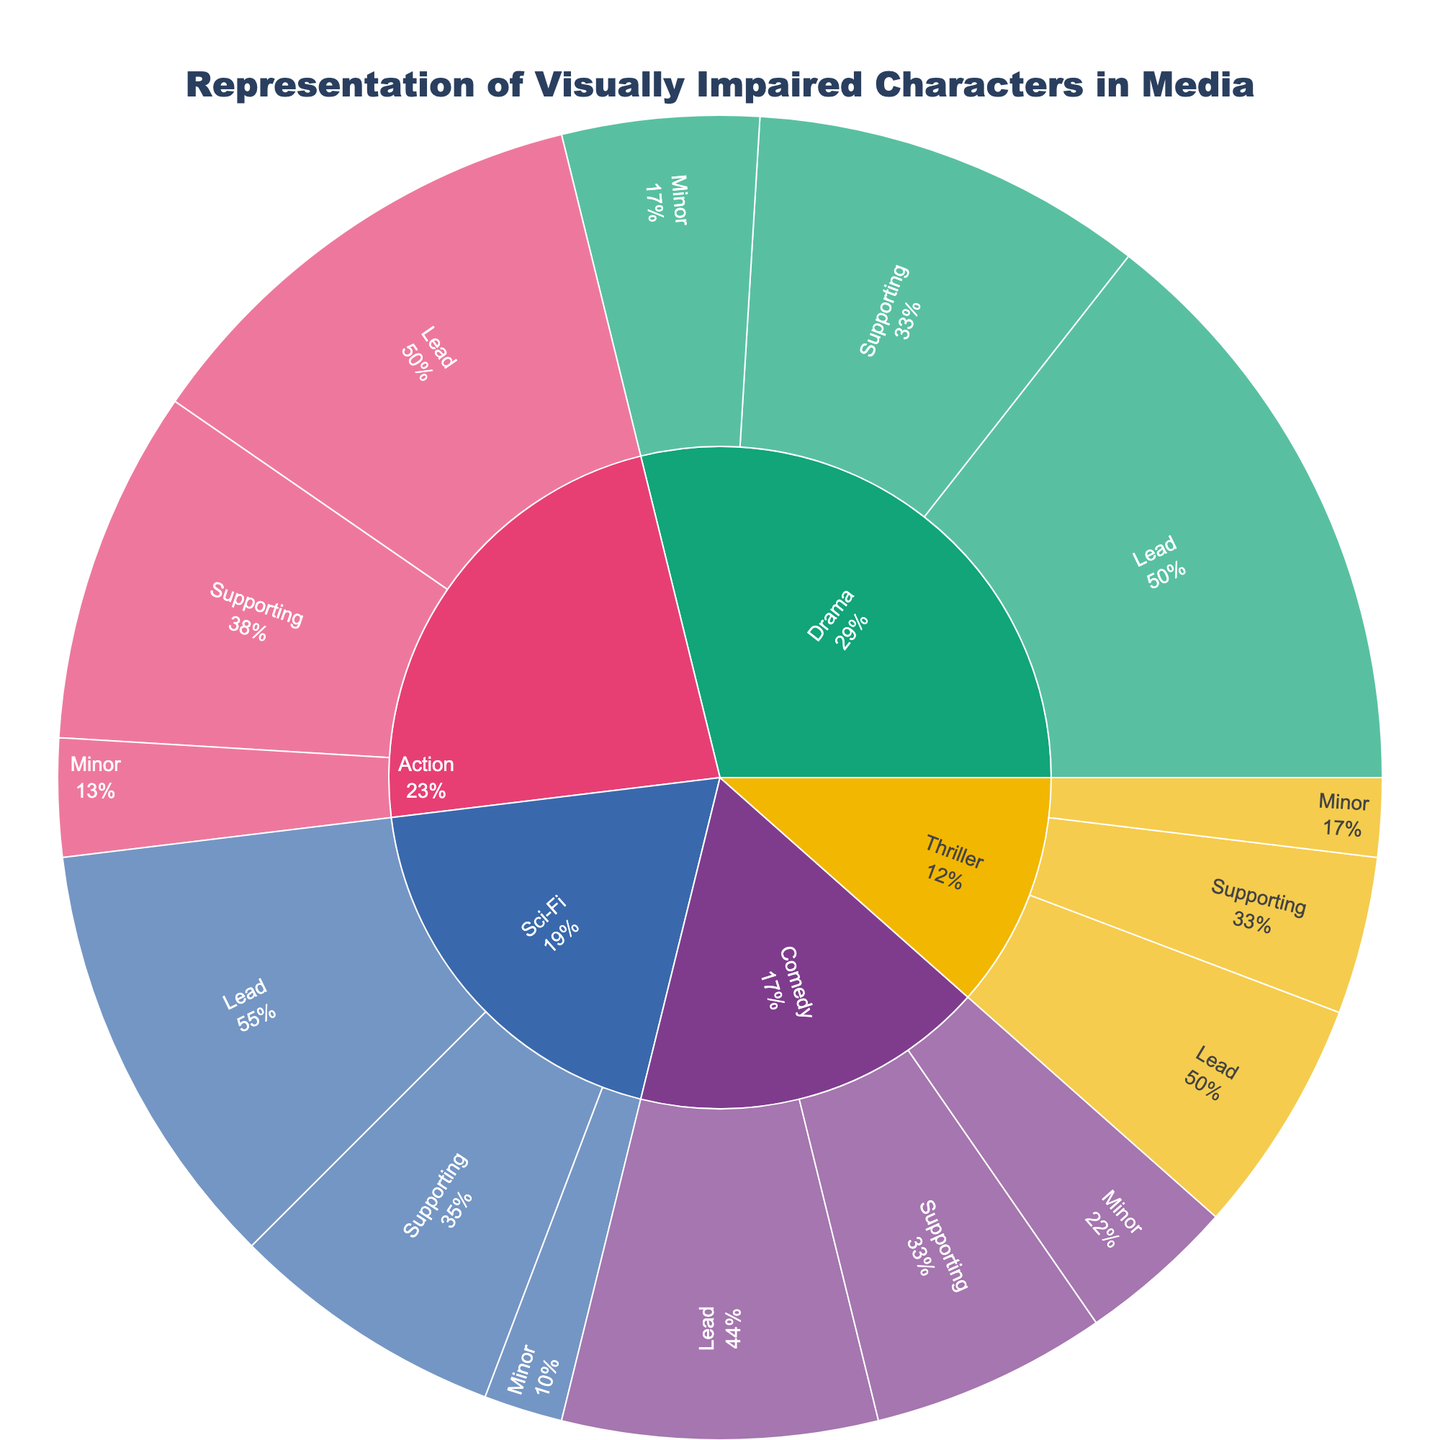What is the title of the Sunburst Plot? The title of the plot is positioned at the top of the figure. It typically describes the main theme or content of the plot.
Answer: Representation of Visually Impaired Characters in Media Which genre has the highest representation percentage for lead roles? To find this, look at the lead role segment in different genres and compare their representation percentages.
Answer: Drama How many genres are represented in the plot? The number of genres will be shown as the primary segmented outer ring in the sunburst plot. Count each unique segment.
Answer: 5 Which character has the highest representation percentage in the Action genre? Within the Action genre's inner segments, identify the character with the highest percentage.
Answer: Chirrut Îmwe (Rogue One) What's the combined representation percentage of supporting roles in Comedy and Sci-Fi? Find the representation percentages for supporting roles in Comedy and Sci-Fi, then sum them up: Comedy (6%) and Sci-Fi (7%). Thus, 6 + 7 = 13.
Answer: 13% Which character from the Thriller genre has the lowest representation percentage? Within the Thriller genre's segments, find the character with the smallest representation percentage.
Answer: Annie (Bird Box) Compare the representation percentage of lead roles between Drama and Sci-Fi genres. Which is higher? Look for the percentages of lead roles in both Drama (15%) and Sci-Fi (11%), and compare them.
Answer: Drama How does the sum of the minor roles' representation percentages across all genres compare to that of the supporting roles across all genres? Add the percentages of minor roles: Drama (5) + Comedy (4) + Action (3) + Sci-Fi (2) + Thriller (2) = 16. Do the same for supporting roles: Drama (10) + Comedy (6) + Action (9) + Sci-Fi (7) + Thriller (4) = 36. Then compare 16 and 36.
Answer: Supporting roles have a higher combined percentage What is the percentage difference between the highest and lowest represented genres? Identify the highest and lowest representation percentages among the genres and find the difference. Drama (30) is the highest, and Thriller (12) is the lowest. So, 30 - 12 = 18
Answer: 18% Which genre has the closest representation percentage between lead and supporting roles? Calculate the absolute differences between the lead and supporting roles for each genre, then find the smallest difference. Drama: 15-10=5, Comedy: 8-6=2, Action: 12-9=3, Sci-Fi: 11-7=4, Thriller: 6-4=2. Comedy and Thriller have the smallest difference.
Answer: Comedy and Thriller 